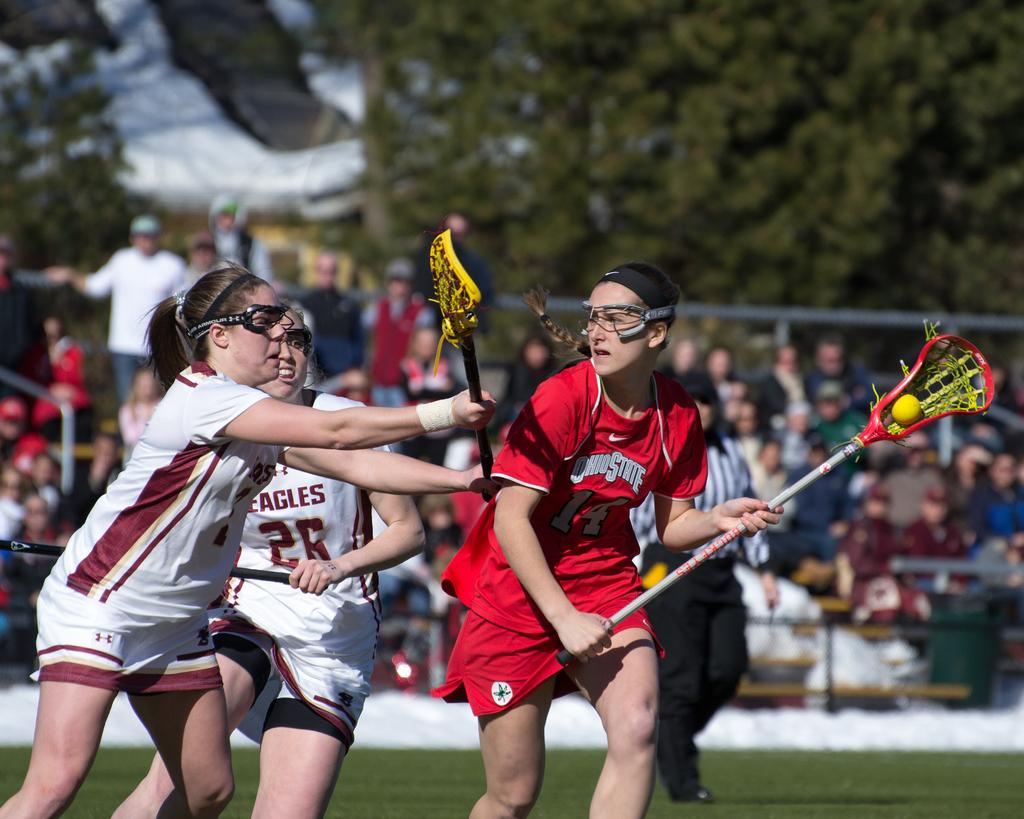<image>
Offer a succinct explanation of the picture presented. One female lacrosse player tries to get the ball away from her opponent who plays for Ohio State. 